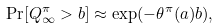Convert formula to latex. <formula><loc_0><loc_0><loc_500><loc_500>\Pr [ Q ^ { \pi } _ { \infty } > b ] \approx \exp ( - \theta ^ { \pi } ( a ) b ) ,</formula> 